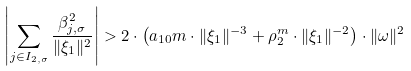Convert formula to latex. <formula><loc_0><loc_0><loc_500><loc_500>\left | \sum _ { j \in I _ { 2 , \sigma } } \frac { \beta _ { j , \sigma } ^ { 2 } } { \| \xi _ { 1 } \| ^ { 2 } } \right | > 2 \cdot \left ( a _ { 1 0 } m \cdot \| \xi _ { 1 } \| ^ { - 3 } + \rho _ { 2 } ^ { m } \cdot \| \xi _ { 1 } \| ^ { - 2 } \right ) \cdot \| \omega \| ^ { 2 }</formula> 